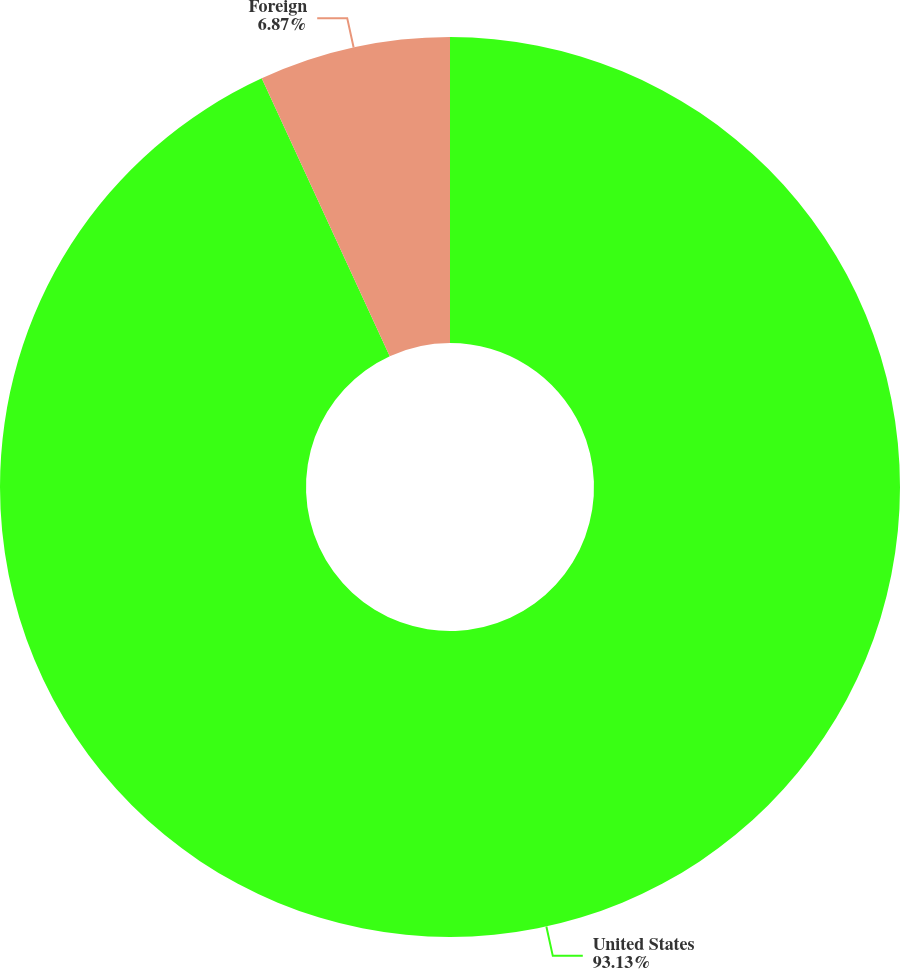Convert chart. <chart><loc_0><loc_0><loc_500><loc_500><pie_chart><fcel>United States<fcel>Foreign<nl><fcel>93.13%<fcel>6.87%<nl></chart> 